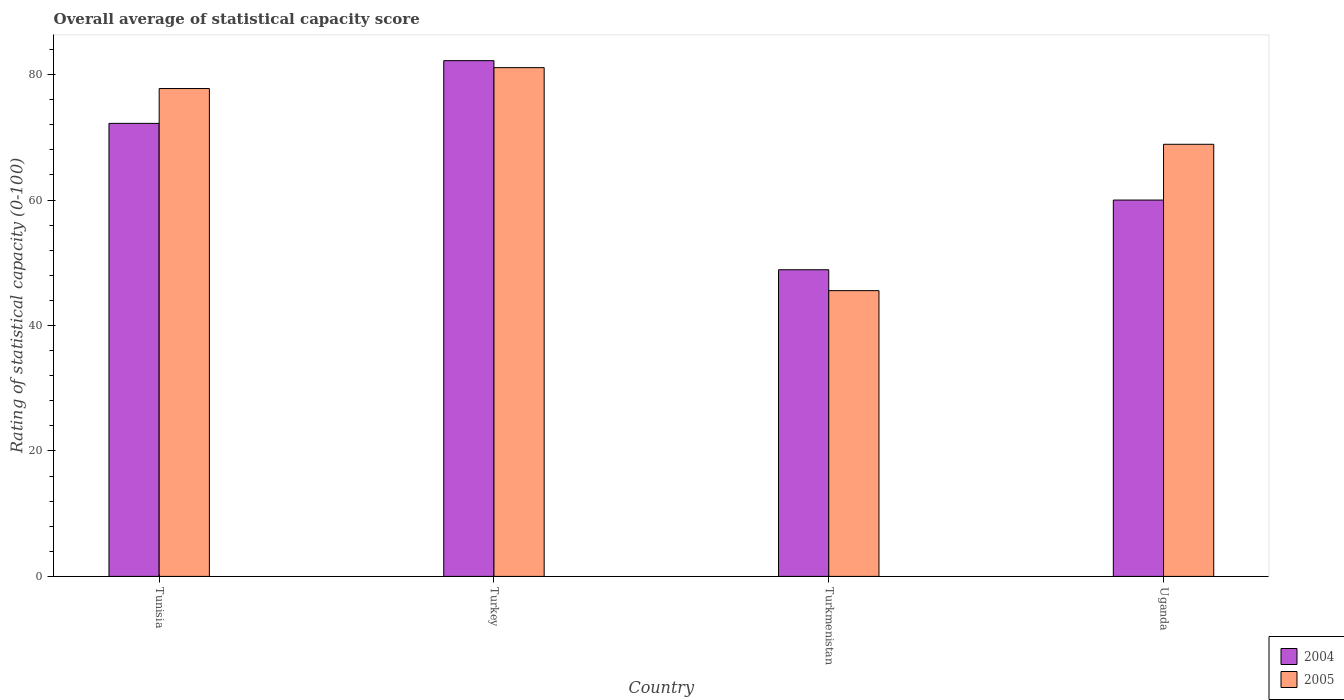Are the number of bars per tick equal to the number of legend labels?
Ensure brevity in your answer.  Yes. How many bars are there on the 3rd tick from the left?
Your answer should be very brief. 2. How many bars are there on the 2nd tick from the right?
Ensure brevity in your answer.  2. What is the label of the 3rd group of bars from the left?
Provide a succinct answer. Turkmenistan. What is the rating of statistical capacity in 2004 in Turkmenistan?
Offer a terse response. 48.89. Across all countries, what is the maximum rating of statistical capacity in 2004?
Keep it short and to the point. 82.22. Across all countries, what is the minimum rating of statistical capacity in 2004?
Your answer should be compact. 48.89. In which country was the rating of statistical capacity in 2005 minimum?
Offer a very short reply. Turkmenistan. What is the total rating of statistical capacity in 2005 in the graph?
Provide a short and direct response. 273.33. What is the difference between the rating of statistical capacity in 2004 in Turkmenistan and that in Uganda?
Ensure brevity in your answer.  -11.11. What is the difference between the rating of statistical capacity in 2004 in Uganda and the rating of statistical capacity in 2005 in Tunisia?
Provide a succinct answer. -17.78. What is the average rating of statistical capacity in 2005 per country?
Ensure brevity in your answer.  68.33. What is the difference between the rating of statistical capacity of/in 2004 and rating of statistical capacity of/in 2005 in Turkmenistan?
Ensure brevity in your answer.  3.33. In how many countries, is the rating of statistical capacity in 2004 greater than 36?
Offer a very short reply. 4. What is the ratio of the rating of statistical capacity in 2005 in Tunisia to that in Turkey?
Ensure brevity in your answer.  0.96. What is the difference between the highest and the second highest rating of statistical capacity in 2005?
Keep it short and to the point. 12.22. What is the difference between the highest and the lowest rating of statistical capacity in 2004?
Ensure brevity in your answer.  33.33. What does the 1st bar from the right in Tunisia represents?
Your answer should be very brief. 2005. Are all the bars in the graph horizontal?
Ensure brevity in your answer.  No. How many countries are there in the graph?
Keep it short and to the point. 4. Are the values on the major ticks of Y-axis written in scientific E-notation?
Your response must be concise. No. What is the title of the graph?
Your response must be concise. Overall average of statistical capacity score. What is the label or title of the X-axis?
Make the answer very short. Country. What is the label or title of the Y-axis?
Offer a terse response. Rating of statistical capacity (0-100). What is the Rating of statistical capacity (0-100) of 2004 in Tunisia?
Offer a very short reply. 72.22. What is the Rating of statistical capacity (0-100) in 2005 in Tunisia?
Offer a very short reply. 77.78. What is the Rating of statistical capacity (0-100) in 2004 in Turkey?
Provide a short and direct response. 82.22. What is the Rating of statistical capacity (0-100) of 2005 in Turkey?
Your answer should be very brief. 81.11. What is the Rating of statistical capacity (0-100) in 2004 in Turkmenistan?
Ensure brevity in your answer.  48.89. What is the Rating of statistical capacity (0-100) of 2005 in Turkmenistan?
Offer a terse response. 45.56. What is the Rating of statistical capacity (0-100) of 2004 in Uganda?
Make the answer very short. 60. What is the Rating of statistical capacity (0-100) of 2005 in Uganda?
Give a very brief answer. 68.89. Across all countries, what is the maximum Rating of statistical capacity (0-100) in 2004?
Provide a succinct answer. 82.22. Across all countries, what is the maximum Rating of statistical capacity (0-100) in 2005?
Provide a short and direct response. 81.11. Across all countries, what is the minimum Rating of statistical capacity (0-100) in 2004?
Your response must be concise. 48.89. Across all countries, what is the minimum Rating of statistical capacity (0-100) in 2005?
Your answer should be compact. 45.56. What is the total Rating of statistical capacity (0-100) in 2004 in the graph?
Ensure brevity in your answer.  263.33. What is the total Rating of statistical capacity (0-100) in 2005 in the graph?
Give a very brief answer. 273.33. What is the difference between the Rating of statistical capacity (0-100) of 2004 in Tunisia and that in Turkmenistan?
Offer a very short reply. 23.33. What is the difference between the Rating of statistical capacity (0-100) of 2005 in Tunisia and that in Turkmenistan?
Give a very brief answer. 32.22. What is the difference between the Rating of statistical capacity (0-100) in 2004 in Tunisia and that in Uganda?
Your answer should be very brief. 12.22. What is the difference between the Rating of statistical capacity (0-100) of 2005 in Tunisia and that in Uganda?
Keep it short and to the point. 8.89. What is the difference between the Rating of statistical capacity (0-100) of 2004 in Turkey and that in Turkmenistan?
Ensure brevity in your answer.  33.33. What is the difference between the Rating of statistical capacity (0-100) in 2005 in Turkey and that in Turkmenistan?
Offer a terse response. 35.56. What is the difference between the Rating of statistical capacity (0-100) of 2004 in Turkey and that in Uganda?
Provide a succinct answer. 22.22. What is the difference between the Rating of statistical capacity (0-100) of 2005 in Turkey and that in Uganda?
Give a very brief answer. 12.22. What is the difference between the Rating of statistical capacity (0-100) in 2004 in Turkmenistan and that in Uganda?
Your answer should be compact. -11.11. What is the difference between the Rating of statistical capacity (0-100) in 2005 in Turkmenistan and that in Uganda?
Ensure brevity in your answer.  -23.33. What is the difference between the Rating of statistical capacity (0-100) in 2004 in Tunisia and the Rating of statistical capacity (0-100) in 2005 in Turkey?
Ensure brevity in your answer.  -8.89. What is the difference between the Rating of statistical capacity (0-100) of 2004 in Tunisia and the Rating of statistical capacity (0-100) of 2005 in Turkmenistan?
Ensure brevity in your answer.  26.67. What is the difference between the Rating of statistical capacity (0-100) of 2004 in Turkey and the Rating of statistical capacity (0-100) of 2005 in Turkmenistan?
Offer a terse response. 36.67. What is the difference between the Rating of statistical capacity (0-100) of 2004 in Turkey and the Rating of statistical capacity (0-100) of 2005 in Uganda?
Give a very brief answer. 13.33. What is the difference between the Rating of statistical capacity (0-100) of 2004 in Turkmenistan and the Rating of statistical capacity (0-100) of 2005 in Uganda?
Keep it short and to the point. -20. What is the average Rating of statistical capacity (0-100) in 2004 per country?
Your response must be concise. 65.83. What is the average Rating of statistical capacity (0-100) in 2005 per country?
Offer a terse response. 68.33. What is the difference between the Rating of statistical capacity (0-100) in 2004 and Rating of statistical capacity (0-100) in 2005 in Tunisia?
Provide a succinct answer. -5.56. What is the difference between the Rating of statistical capacity (0-100) in 2004 and Rating of statistical capacity (0-100) in 2005 in Uganda?
Keep it short and to the point. -8.89. What is the ratio of the Rating of statistical capacity (0-100) of 2004 in Tunisia to that in Turkey?
Your response must be concise. 0.88. What is the ratio of the Rating of statistical capacity (0-100) in 2005 in Tunisia to that in Turkey?
Make the answer very short. 0.96. What is the ratio of the Rating of statistical capacity (0-100) of 2004 in Tunisia to that in Turkmenistan?
Offer a very short reply. 1.48. What is the ratio of the Rating of statistical capacity (0-100) of 2005 in Tunisia to that in Turkmenistan?
Make the answer very short. 1.71. What is the ratio of the Rating of statistical capacity (0-100) in 2004 in Tunisia to that in Uganda?
Offer a terse response. 1.2. What is the ratio of the Rating of statistical capacity (0-100) in 2005 in Tunisia to that in Uganda?
Provide a short and direct response. 1.13. What is the ratio of the Rating of statistical capacity (0-100) in 2004 in Turkey to that in Turkmenistan?
Provide a short and direct response. 1.68. What is the ratio of the Rating of statistical capacity (0-100) in 2005 in Turkey to that in Turkmenistan?
Offer a terse response. 1.78. What is the ratio of the Rating of statistical capacity (0-100) of 2004 in Turkey to that in Uganda?
Keep it short and to the point. 1.37. What is the ratio of the Rating of statistical capacity (0-100) in 2005 in Turkey to that in Uganda?
Your answer should be compact. 1.18. What is the ratio of the Rating of statistical capacity (0-100) in 2004 in Turkmenistan to that in Uganda?
Provide a succinct answer. 0.81. What is the ratio of the Rating of statistical capacity (0-100) in 2005 in Turkmenistan to that in Uganda?
Offer a very short reply. 0.66. What is the difference between the highest and the second highest Rating of statistical capacity (0-100) of 2004?
Your answer should be very brief. 10. What is the difference between the highest and the lowest Rating of statistical capacity (0-100) in 2004?
Keep it short and to the point. 33.33. What is the difference between the highest and the lowest Rating of statistical capacity (0-100) of 2005?
Provide a short and direct response. 35.56. 